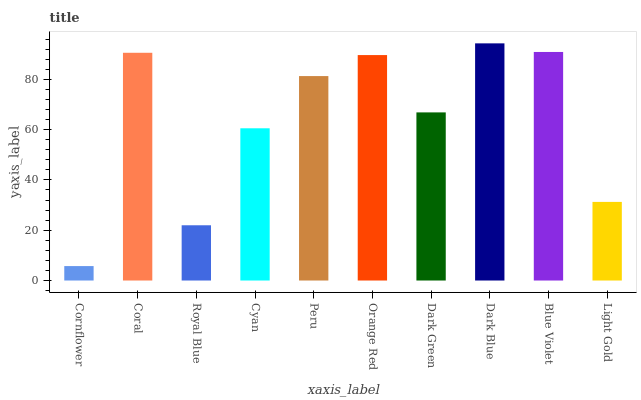Is Cornflower the minimum?
Answer yes or no. Yes. Is Dark Blue the maximum?
Answer yes or no. Yes. Is Coral the minimum?
Answer yes or no. No. Is Coral the maximum?
Answer yes or no. No. Is Coral greater than Cornflower?
Answer yes or no. Yes. Is Cornflower less than Coral?
Answer yes or no. Yes. Is Cornflower greater than Coral?
Answer yes or no. No. Is Coral less than Cornflower?
Answer yes or no. No. Is Peru the high median?
Answer yes or no. Yes. Is Dark Green the low median?
Answer yes or no. Yes. Is Royal Blue the high median?
Answer yes or no. No. Is Peru the low median?
Answer yes or no. No. 